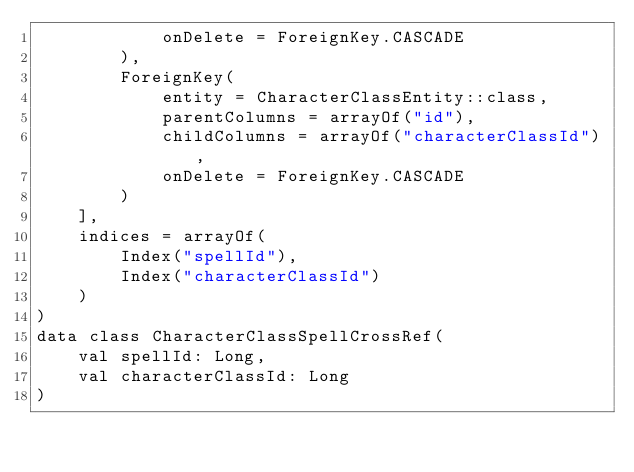Convert code to text. <code><loc_0><loc_0><loc_500><loc_500><_Kotlin_>            onDelete = ForeignKey.CASCADE
        ),
        ForeignKey(
            entity = CharacterClassEntity::class,
            parentColumns = arrayOf("id"),
            childColumns = arrayOf("characterClassId"),
            onDelete = ForeignKey.CASCADE
        )
    ],
    indices = arrayOf(
        Index("spellId"),
        Index("characterClassId")
    )
)
data class CharacterClassSpellCrossRef(
    val spellId: Long,
    val characterClassId: Long
)</code> 